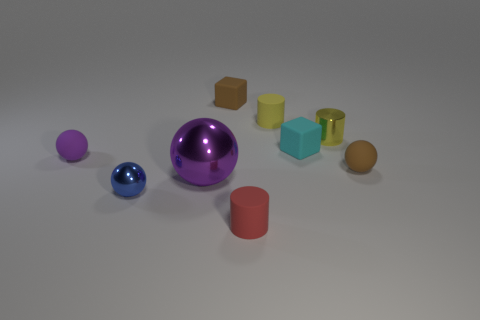There is a brown thing that is in front of the purple ball on the left side of the big purple metallic thing; what size is it?
Your answer should be compact. Small. There is a small ball that is in front of the brown ball; what color is it?
Offer a terse response. Blue. The brown sphere that is the same material as the tiny brown cube is what size?
Offer a very short reply. Small. What number of purple matte things are the same shape as the tiny red rubber thing?
Offer a very short reply. 0. There is a red cylinder that is the same size as the blue object; what is it made of?
Provide a short and direct response. Rubber. Are there any tiny cylinders that have the same material as the tiny red object?
Give a very brief answer. Yes. There is a tiny rubber thing that is in front of the tiny brown block and behind the tiny cyan cube; what is its color?
Provide a succinct answer. Yellow. What number of other things are the same color as the small metallic ball?
Give a very brief answer. 0. What material is the tiny sphere on the right side of the cylinder that is in front of the matte ball that is on the right side of the yellow shiny cylinder?
Your answer should be very brief. Rubber. How many balls are yellow metallic objects or yellow objects?
Your response must be concise. 0. 